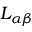<formula> <loc_0><loc_0><loc_500><loc_500>L _ { \alpha \beta }</formula> 